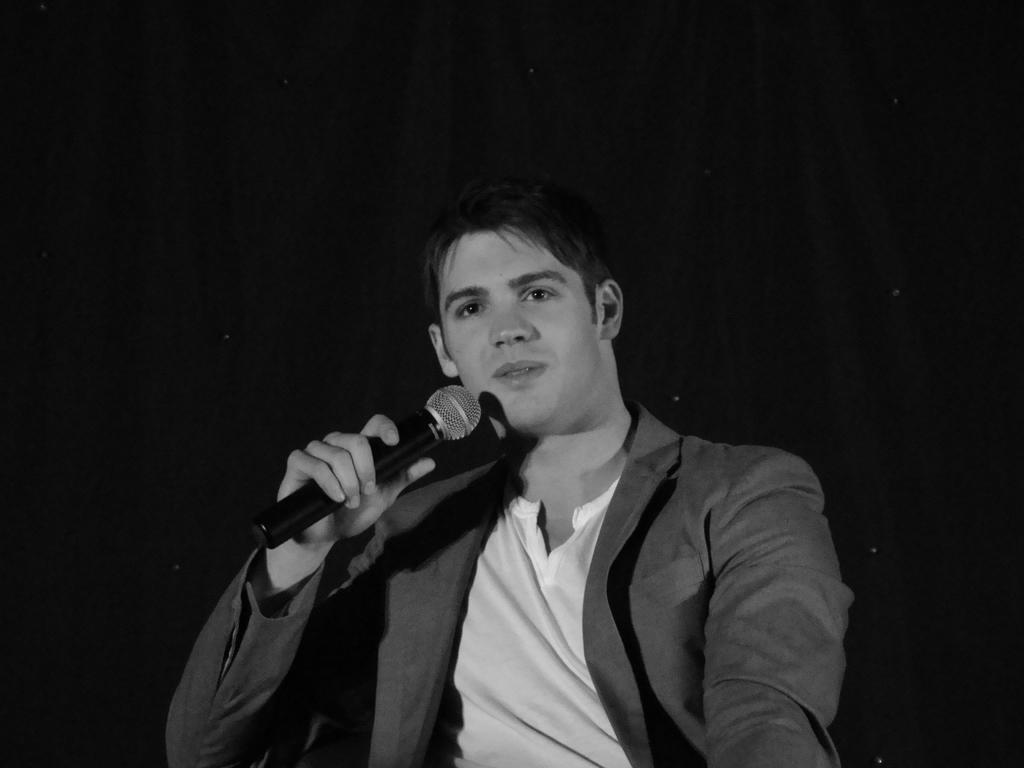Who is the main subject in the image? There is a man in the image. What is the man holding in the image? The man is holding a microphone (mic) in the image. How many apples are on the table next to the man in the image? There is no table or apples present in the image; it only features a man holding a microphone. What type of thunder can be heard in the background of the image? There is no thunder present in the image; it only features a man holding a microphone. 